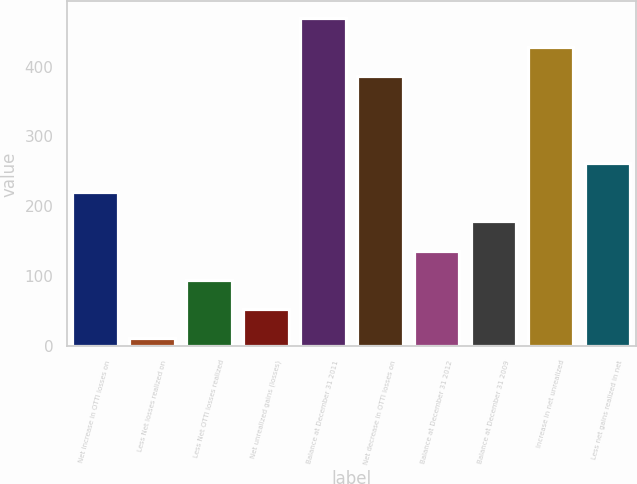Convert chart to OTSL. <chart><loc_0><loc_0><loc_500><loc_500><bar_chart><fcel>Net increase in OTTI losses on<fcel>Less Net losses realized on<fcel>Less Net OTTI losses realized<fcel>Net unrealized gains (losses)<fcel>Balance at December 31 2011<fcel>Net decrease in OTTI losses on<fcel>Balance at December 31 2012<fcel>Balance at December 31 2009<fcel>Increase in net unrealized<fcel>Less net gains realized in net<nl><fcel>220<fcel>12<fcel>95.2<fcel>53.6<fcel>469.6<fcel>386.4<fcel>136.8<fcel>178.4<fcel>428<fcel>261.6<nl></chart> 